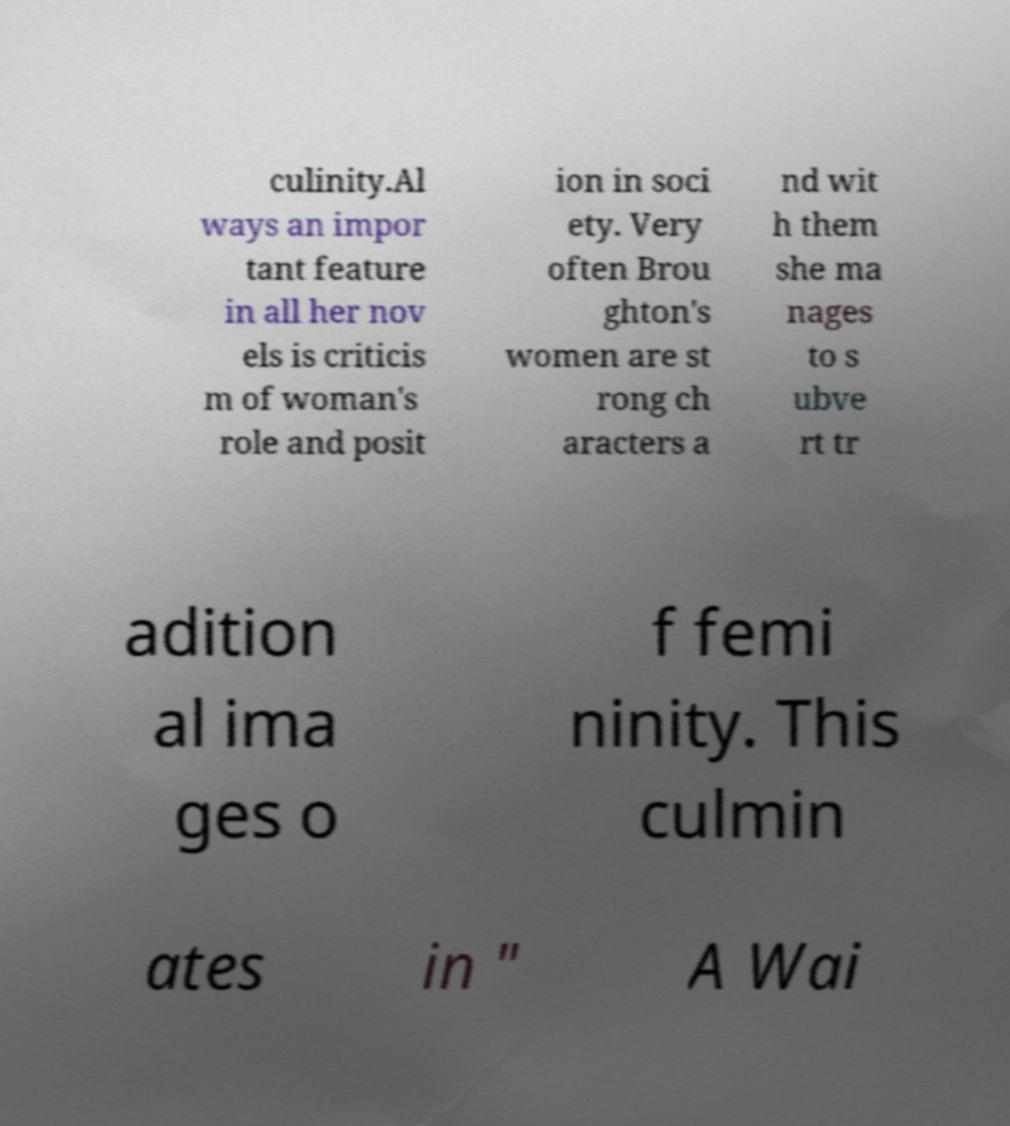I need the written content from this picture converted into text. Can you do that? culinity.Al ways an impor tant feature in all her nov els is criticis m of woman's role and posit ion in soci ety. Very often Brou ghton's women are st rong ch aracters a nd wit h them she ma nages to s ubve rt tr adition al ima ges o f femi ninity. This culmin ates in " A Wai 